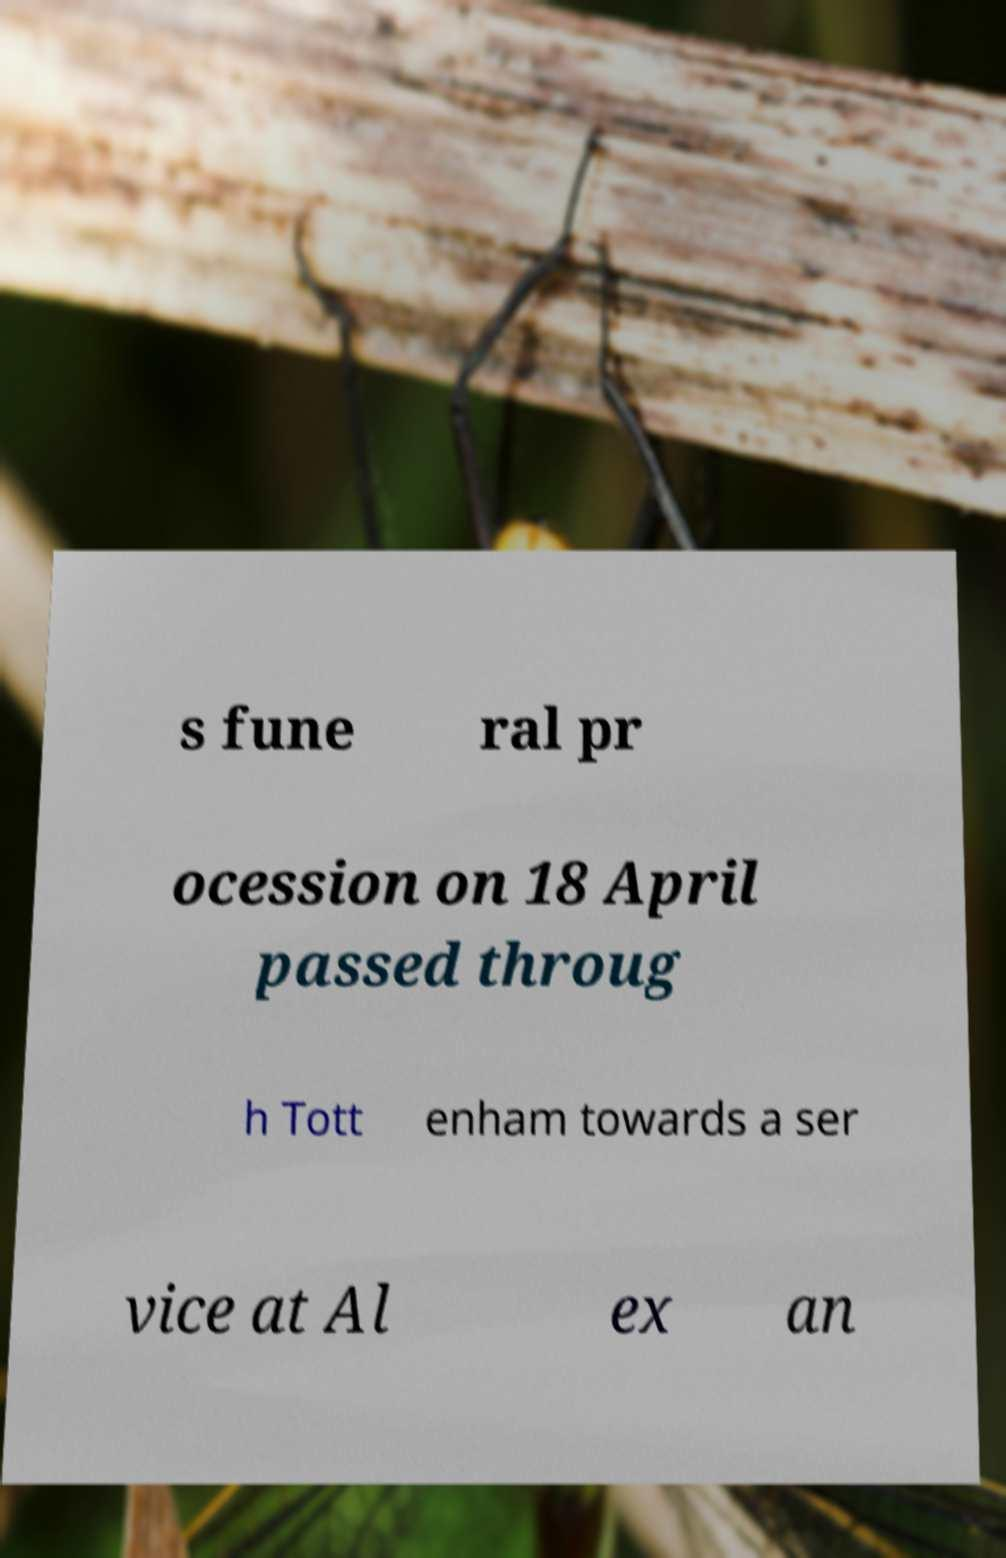Can you read and provide the text displayed in the image?This photo seems to have some interesting text. Can you extract and type it out for me? s fune ral pr ocession on 18 April passed throug h Tott enham towards a ser vice at Al ex an 